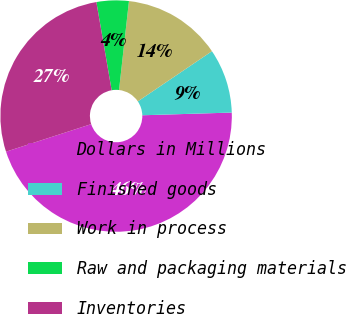Convert chart to OTSL. <chart><loc_0><loc_0><loc_500><loc_500><pie_chart><fcel>Dollars in Millions<fcel>Finished goods<fcel>Work in process<fcel>Raw and packaging materials<fcel>Inventories<nl><fcel>45.5%<fcel>8.99%<fcel>13.76%<fcel>4.5%<fcel>27.25%<nl></chart> 